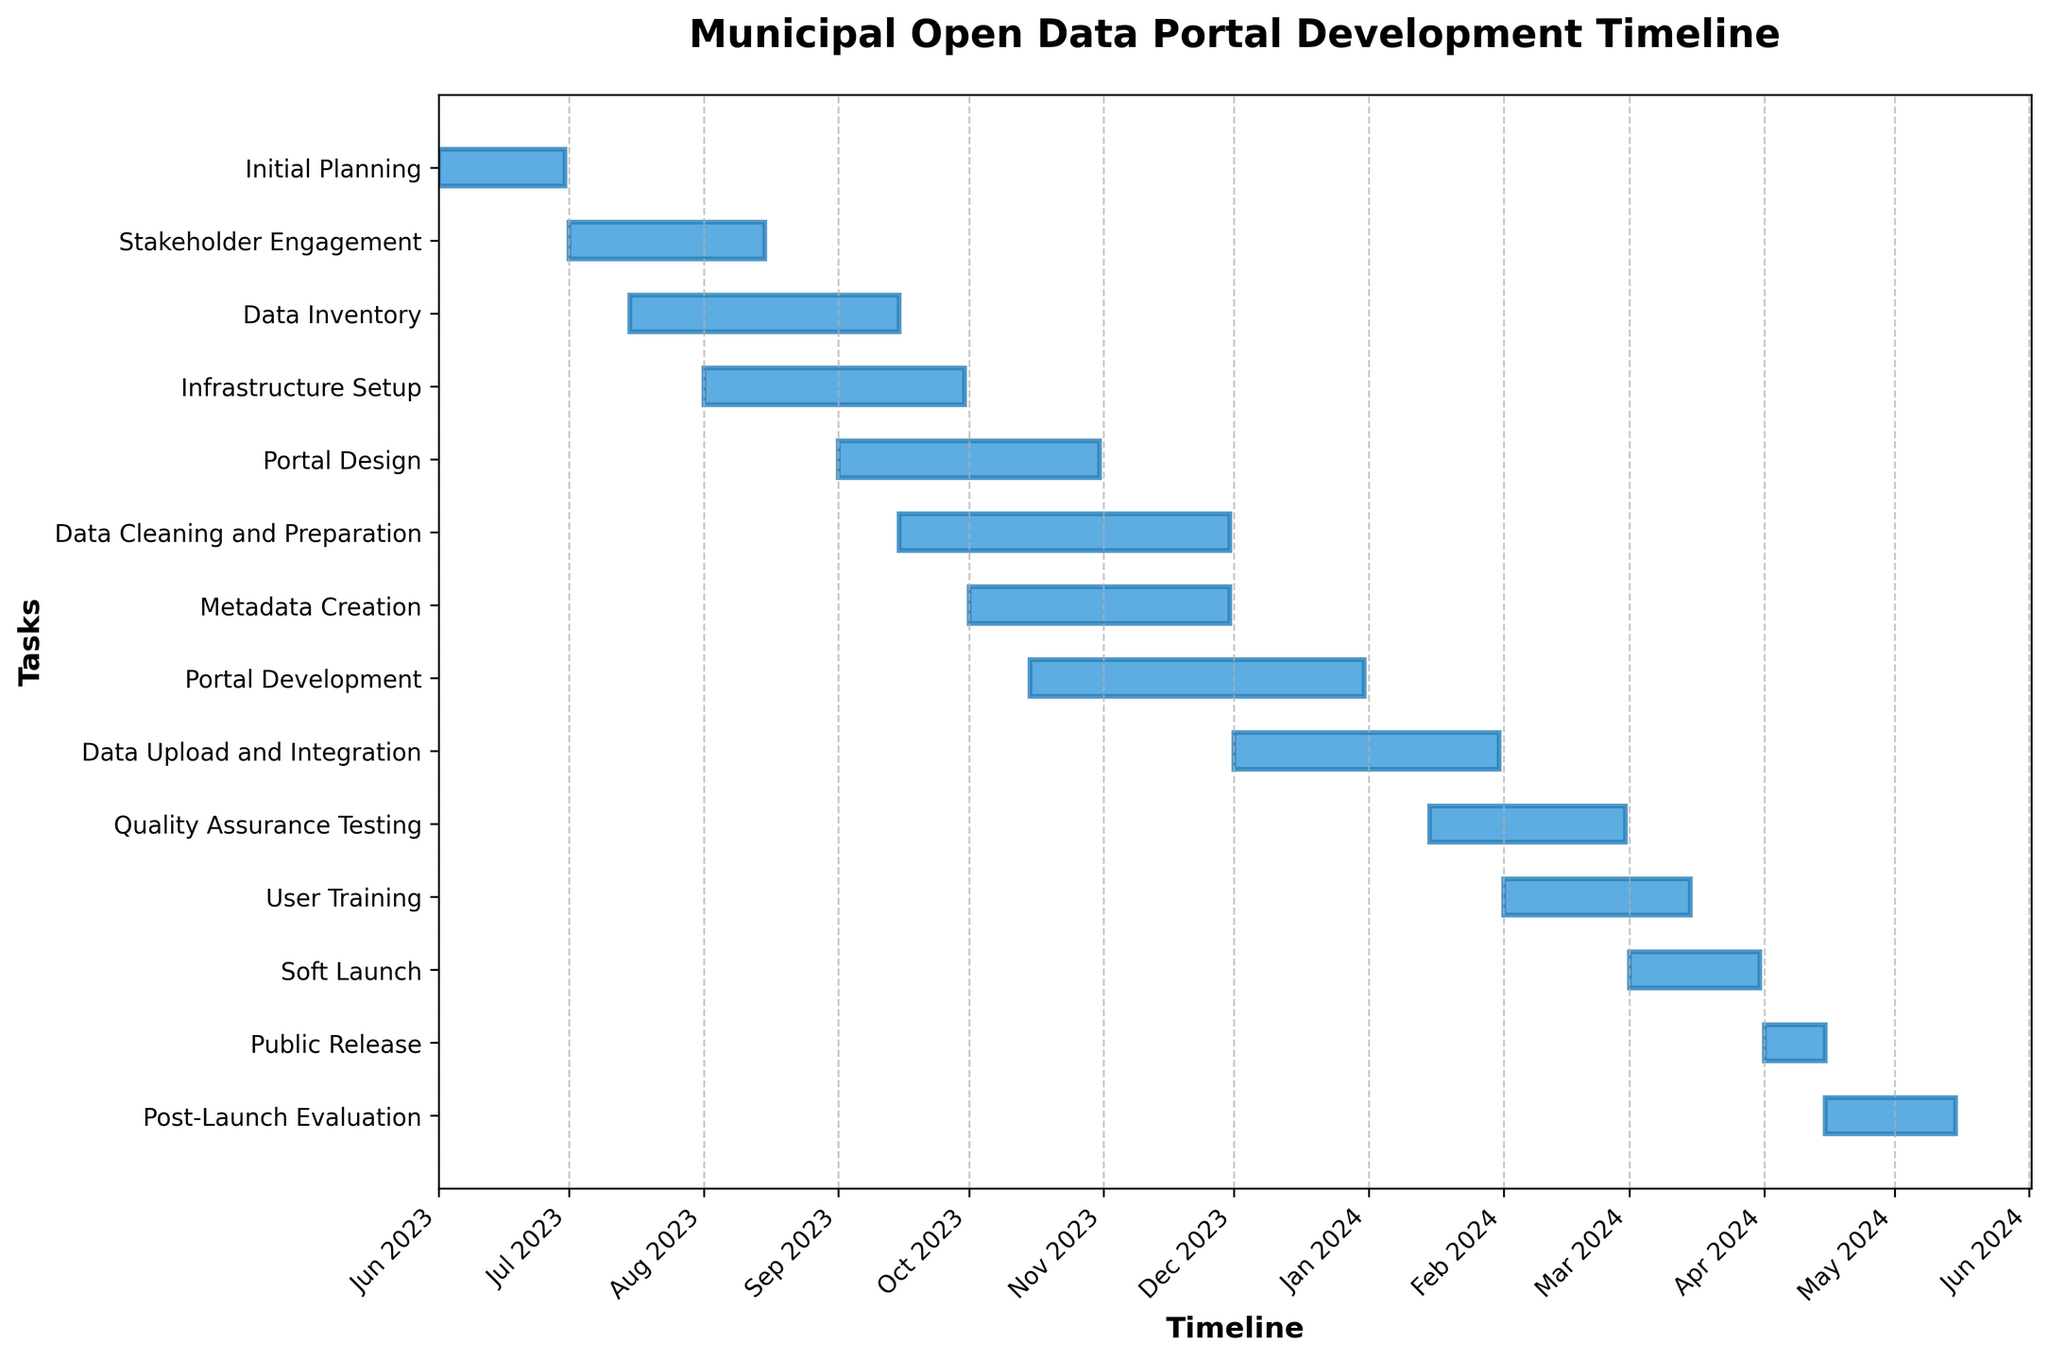what is the title of the chart? The title of the chart is located at the top of the figure.
Answer: Municipal Open Data Portal Development Timeline How many tasks are there in the chart? Count the number of horizontal bars, each representing a different task.
Answer: 13 Which task spans the longest duration? Observe the horizontal bars and compare their lengths. The longest bar represents the task with the longest duration.
Answer: Data Cleaning and Preparation When does the "Stakeholder Engagement" phase end? Locate the bar labeled "Stakeholder Engagement" and check the endpoint on the x-axis.
Answer: August 15, 2023 Which two tasks have overlapping time frames in September 2023? Identify tasks whose bars overlap in September 2023 by examining where their time frames intersect.
Answer: Portal Design and Infrastructure Setup When does the "Quality Assurance Testing" task start? Find the bar for "Quality Assurance Testing" and observe its starting point on the x-axis.
Answer: January 15, 2024 Which task starts immediately after "Initial Planning" ends? Note the end date of "Initial Planning" and find the task that starts the next day.
Answer: Stakeholder Engagement How many tasks are scheduled to overlap in October 2023? Identify the tasks whose bars cover October 2023. Count those tasks.
Answer: 4 tasks What is the combined duration of "Metadata Creation" and "Portal Development"? Calculate the durations of these tasks and add them together. "Metadata Creation" runs from October 1, 2023, to November 30, 2023, which is 61 days. "Portal Development" runs from October 15, 2023, to December 31, 2023, which is 78 days. So, 61 + 78 = 139 days.
Answer: 139 days Which phase is the last task to be completed by April 2024? Locate the timeline and find which task finishes last in April 2024.
Answer: Post-Launch Evaluation 